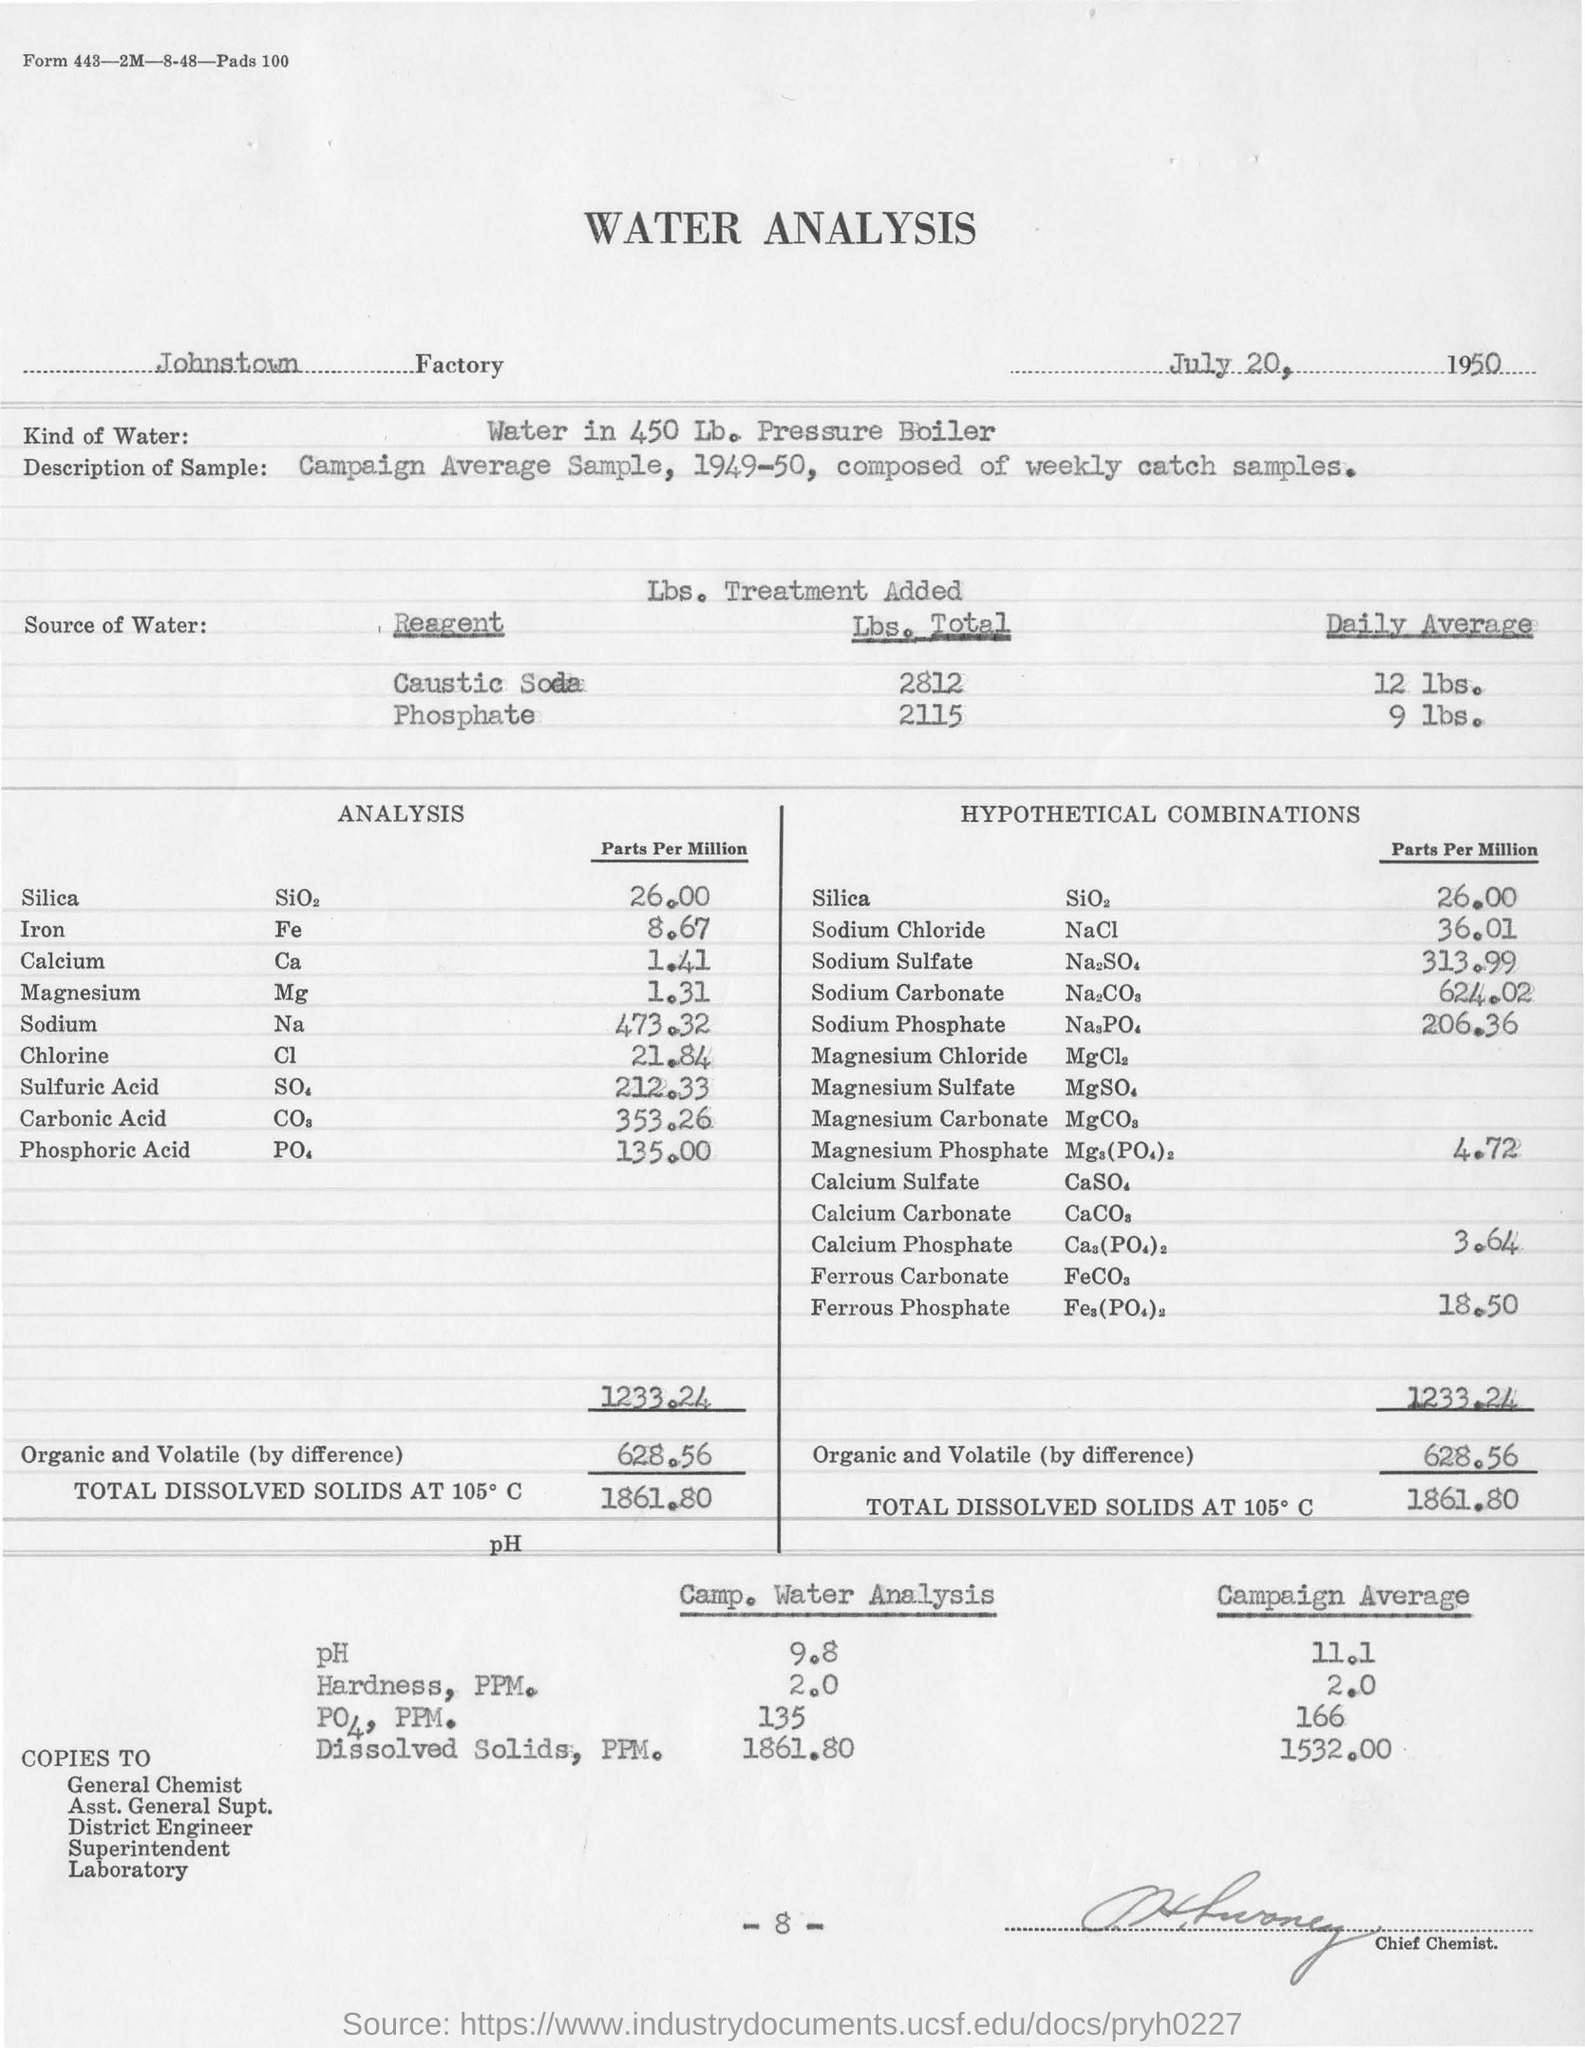List a handful of essential elements in this visual. The date mentioned alongside the factory name is July 20, 1950. The pH level in the camp water analysis is 9.8. The Johnstown factory is being considered for water analysis. The main heading "WATER ANALYSIS" mentions the analysis of water. 